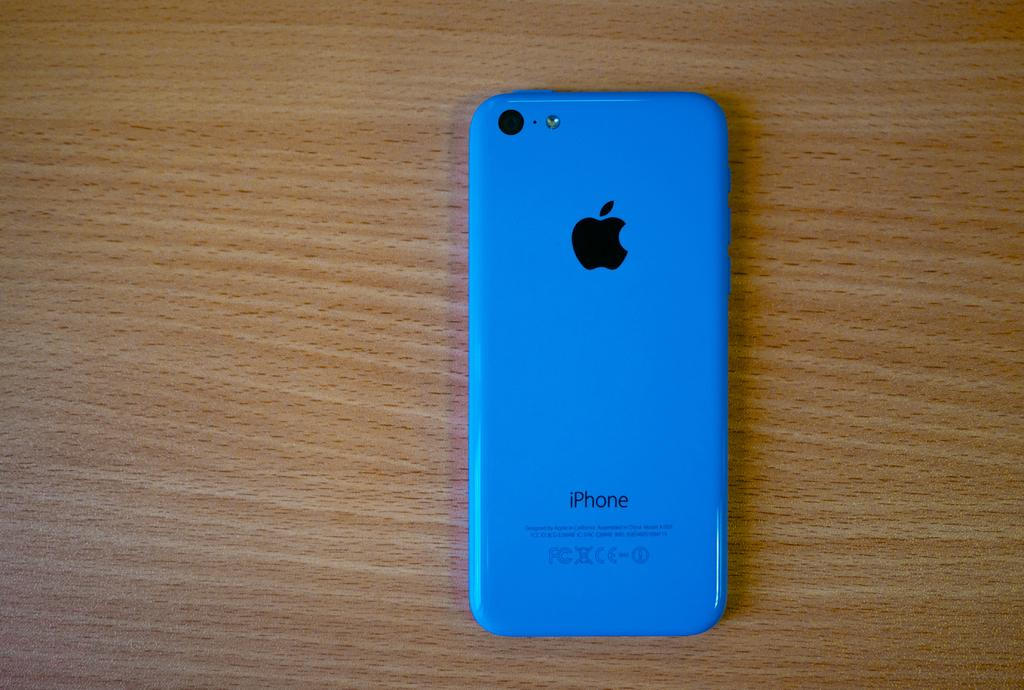<image>
Present a compact description of the photo's key features. A blue iPhone laying face down on a wooden table 